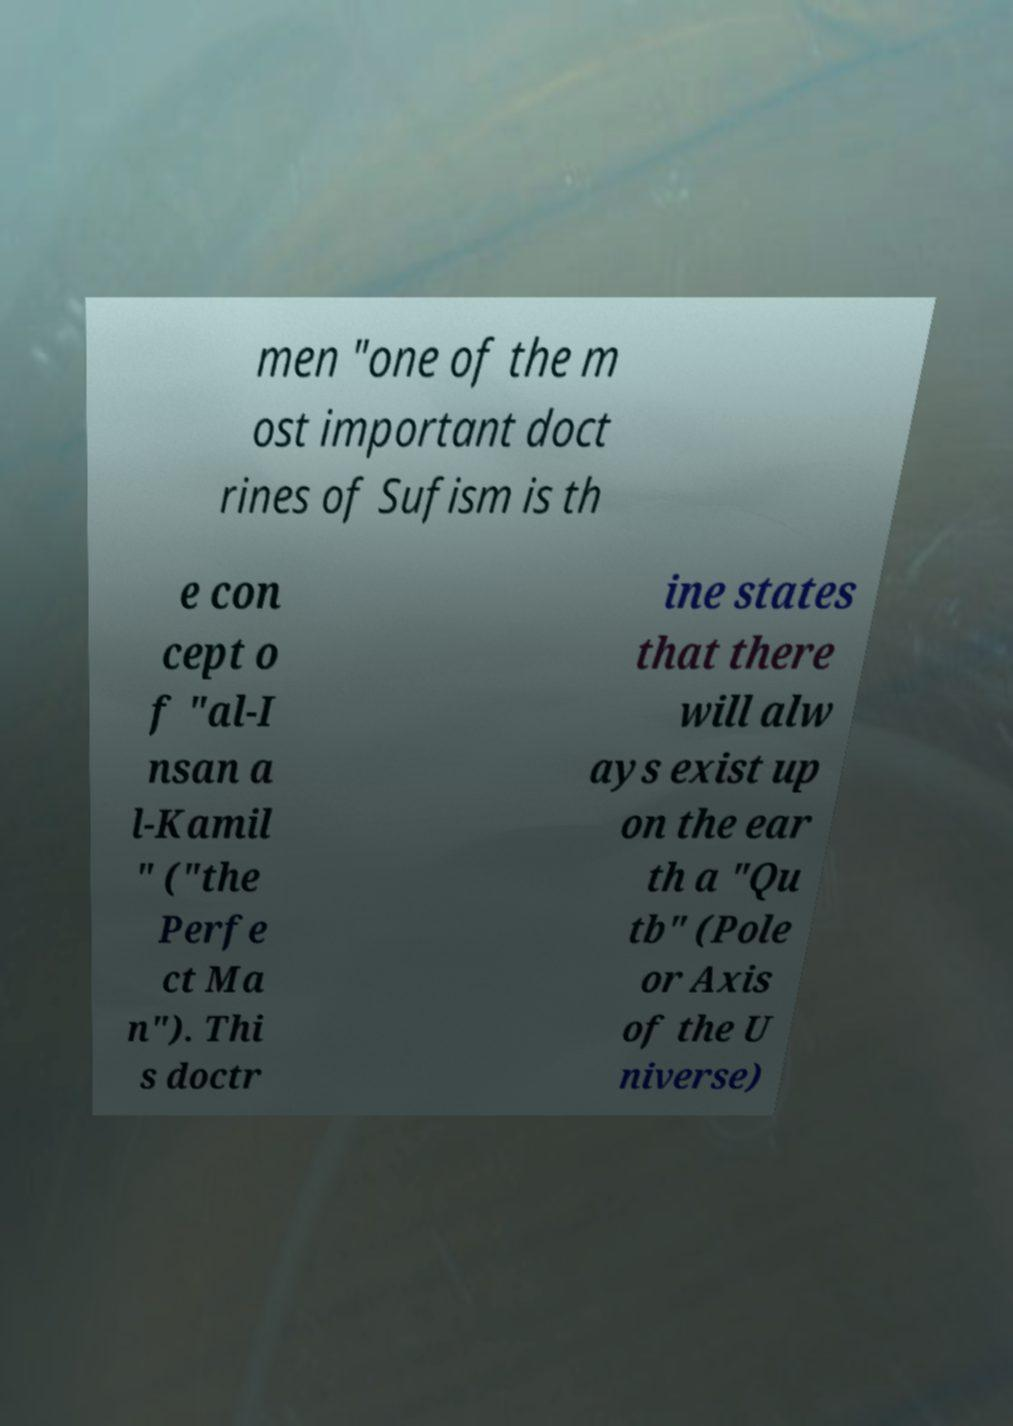Can you accurately transcribe the text from the provided image for me? men "one of the m ost important doct rines of Sufism is th e con cept o f "al-I nsan a l-Kamil " ("the Perfe ct Ma n"). Thi s doctr ine states that there will alw ays exist up on the ear th a "Qu tb" (Pole or Axis of the U niverse) 